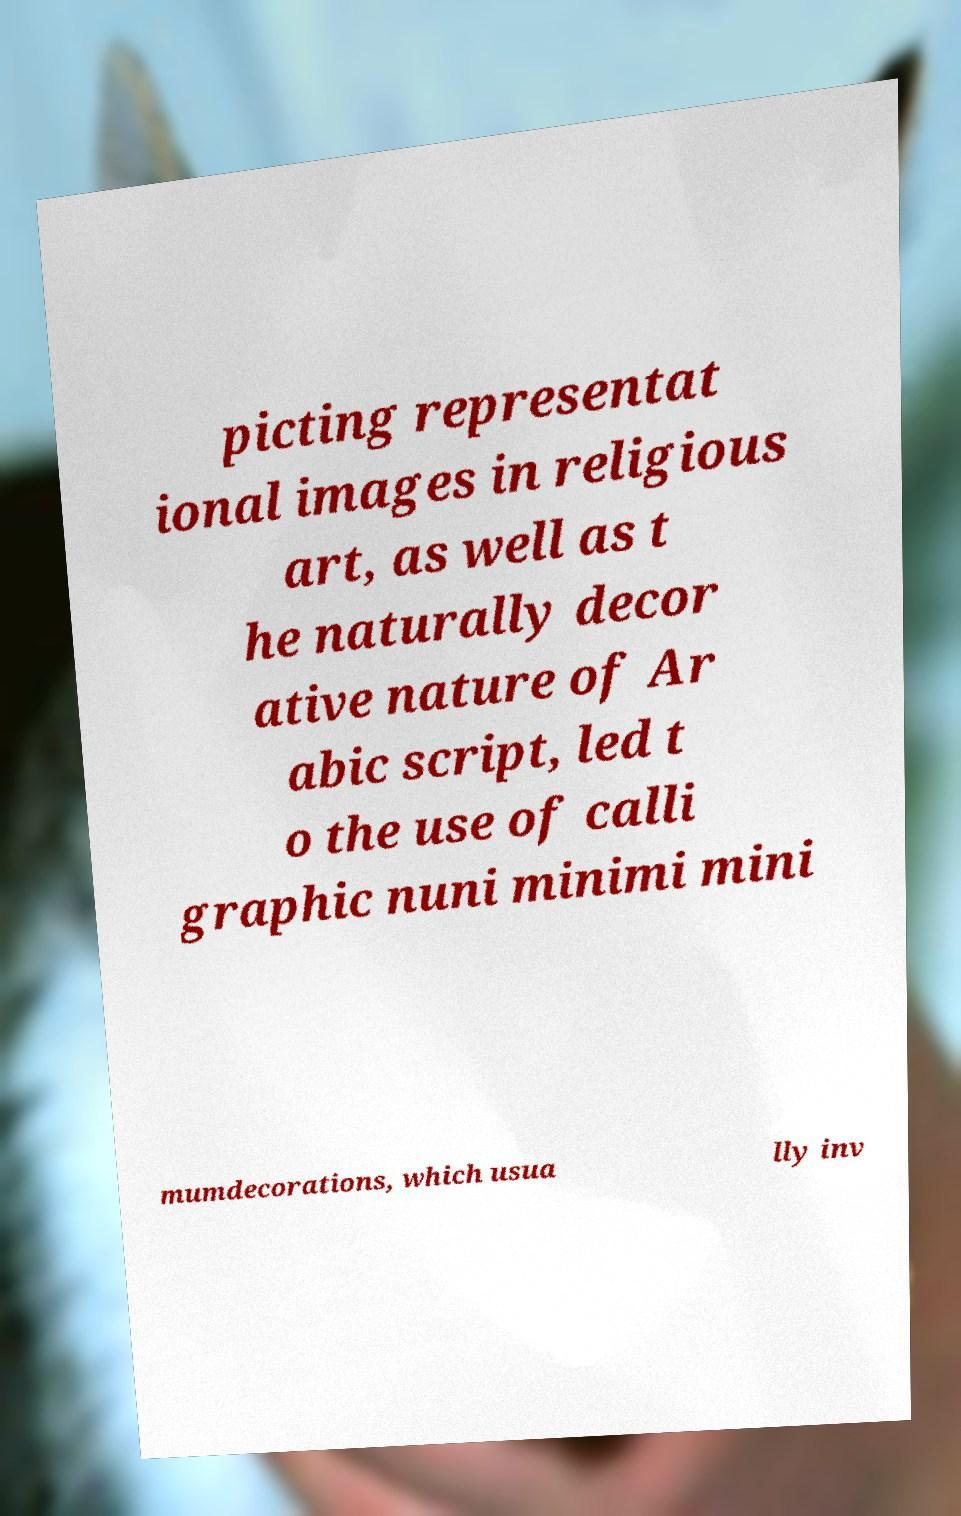I need the written content from this picture converted into text. Can you do that? picting representat ional images in religious art, as well as t he naturally decor ative nature of Ar abic script, led t o the use of calli graphic nuni minimi mini mumdecorations, which usua lly inv 